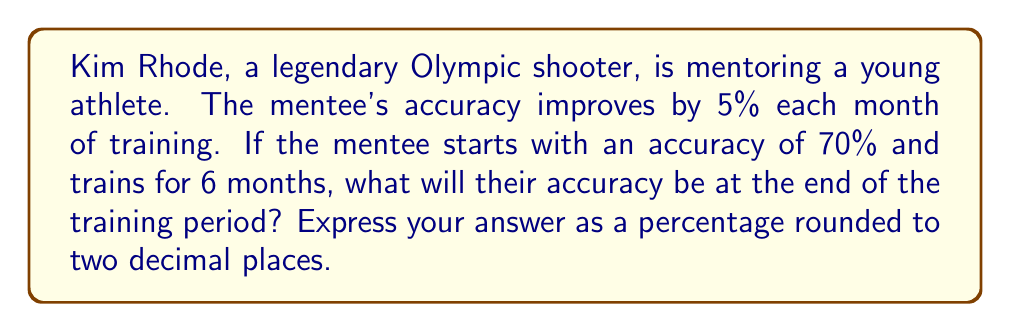Can you solve this math problem? Let's approach this step-by-step:

1) The initial accuracy is 70% or 0.70 in decimal form.

2) The improvement rate is 5% or 0.05 per month.

3) We can model this as exponential growth. The formula for exponential growth is:

   $$A = P(1 + r)^t$$

   Where:
   $A$ = Final amount
   $P$ = Initial amount
   $r$ = Growth rate (as a decimal)
   $t$ = Number of time periods

4) Plugging in our values:

   $$A = 0.70(1 + 0.05)^6$$

5) Let's calculate:

   $$A = 0.70(1.05)^6$$
   $$A = 0.70(1.3401)$$
   $$A = 0.9380$$

6) Converting to a percentage:

   $$0.9380 * 100 = 93.80\%$$

Therefore, after 6 months of training, the mentee's accuracy will be 93.80%.
Answer: 93.80% 